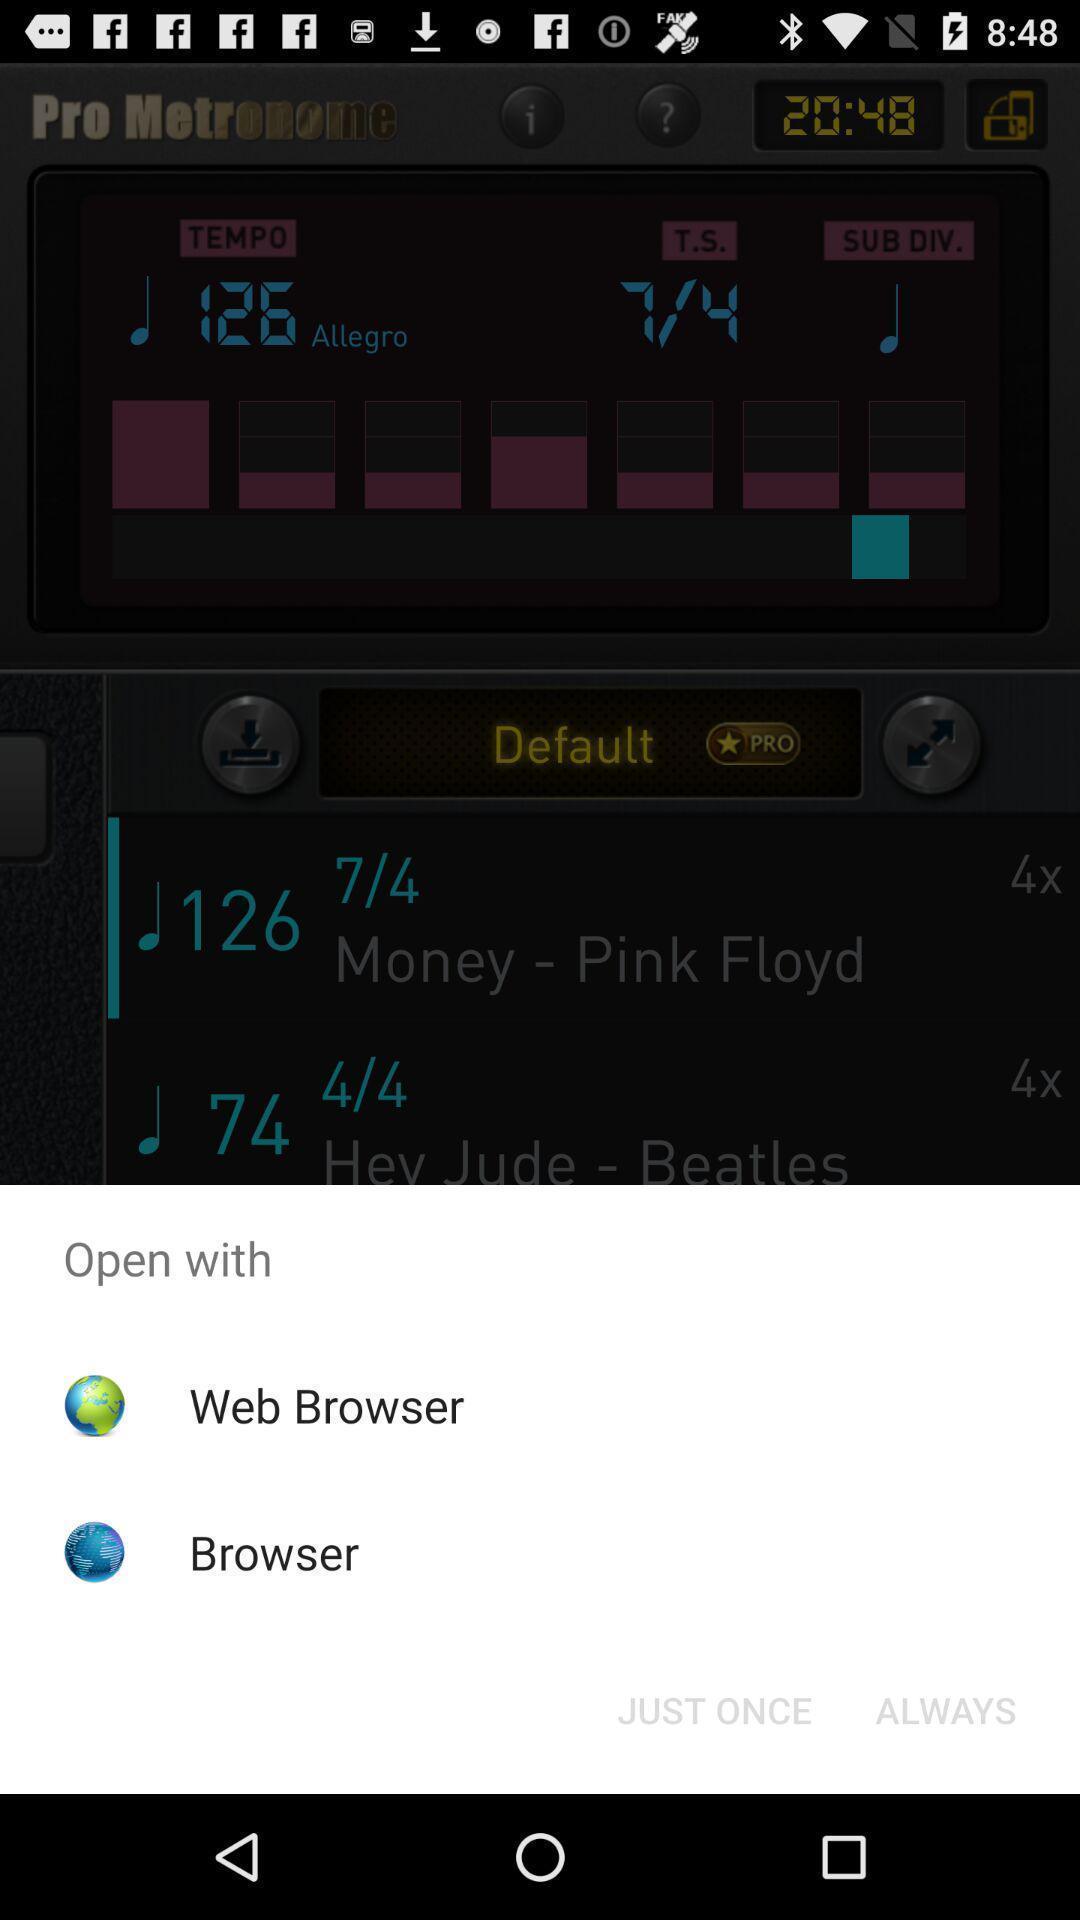Give me a summary of this screen capture. Pop-up for the web browsers with icons. 